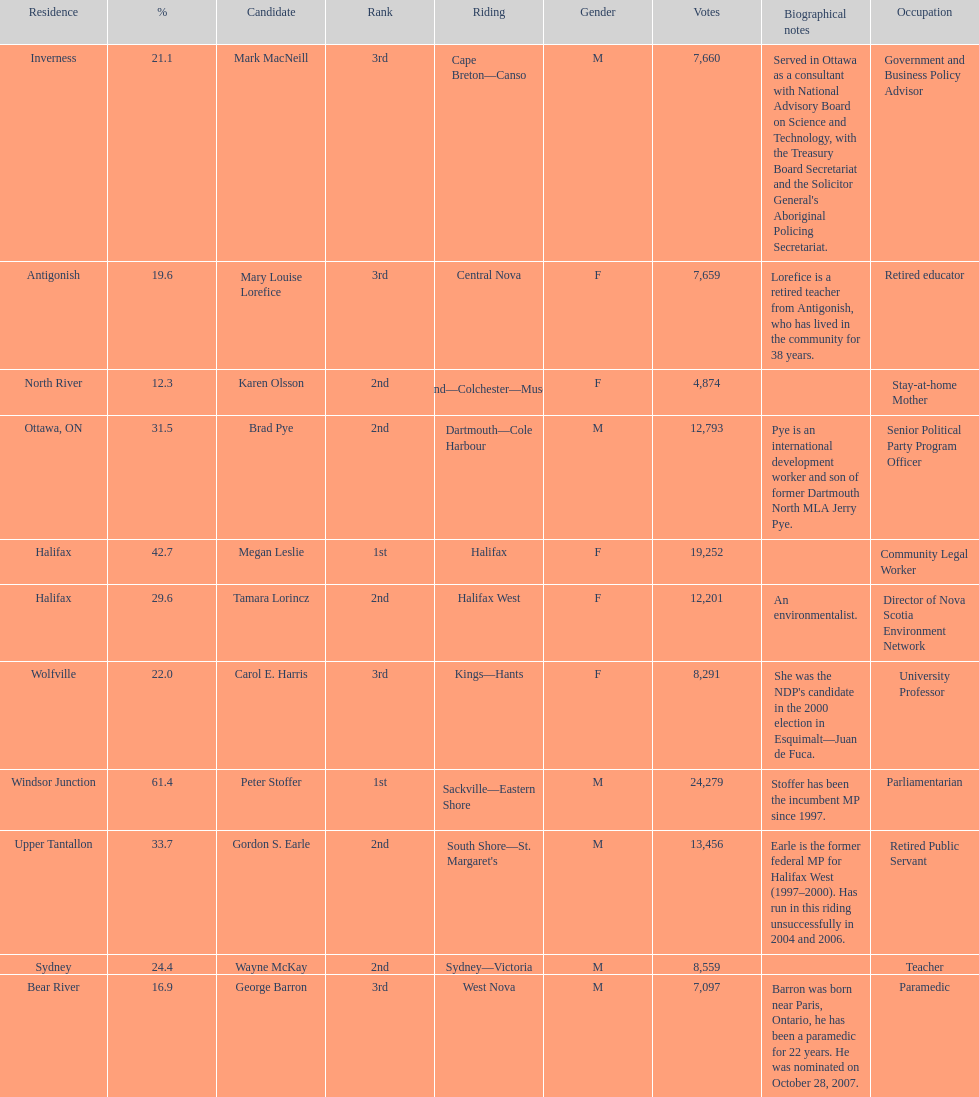Who are all the candidates? Mark MacNeill, Mary Louise Lorefice, Karen Olsson, Brad Pye, Megan Leslie, Tamara Lorincz, Carol E. Harris, Peter Stoffer, Gordon S. Earle, Wayne McKay, George Barron. How many votes did they receive? 7,660, 7,659, 4,874, 12,793, 19,252, 12,201, 8,291, 24,279, 13,456, 8,559, 7,097. And of those, how many were for megan leslie? 19,252. 